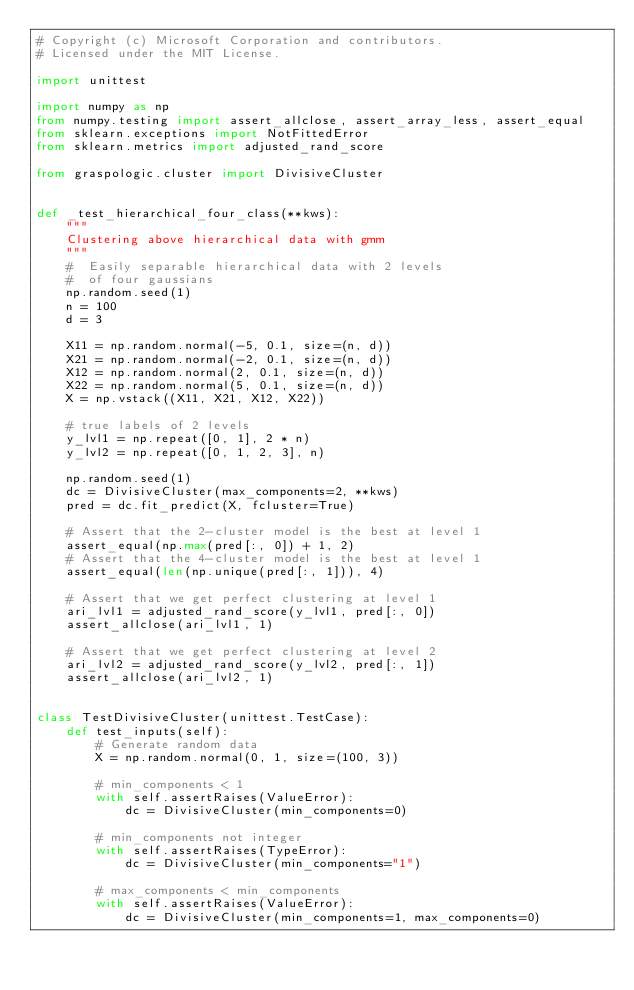<code> <loc_0><loc_0><loc_500><loc_500><_Python_># Copyright (c) Microsoft Corporation and contributors.
# Licensed under the MIT License.

import unittest

import numpy as np
from numpy.testing import assert_allclose, assert_array_less, assert_equal
from sklearn.exceptions import NotFittedError
from sklearn.metrics import adjusted_rand_score

from graspologic.cluster import DivisiveCluster


def _test_hierarchical_four_class(**kws):
    """
    Clustering above hierarchical data with gmm
    """
    #  Easily separable hierarchical data with 2 levels
    #  of four gaussians
    np.random.seed(1)
    n = 100
    d = 3

    X11 = np.random.normal(-5, 0.1, size=(n, d))
    X21 = np.random.normal(-2, 0.1, size=(n, d))
    X12 = np.random.normal(2, 0.1, size=(n, d))
    X22 = np.random.normal(5, 0.1, size=(n, d))
    X = np.vstack((X11, X21, X12, X22))

    # true labels of 2 levels
    y_lvl1 = np.repeat([0, 1], 2 * n)
    y_lvl2 = np.repeat([0, 1, 2, 3], n)

    np.random.seed(1)
    dc = DivisiveCluster(max_components=2, **kws)
    pred = dc.fit_predict(X, fcluster=True)

    # Assert that the 2-cluster model is the best at level 1
    assert_equal(np.max(pred[:, 0]) + 1, 2)
    # Assert that the 4-cluster model is the best at level 1
    assert_equal(len(np.unique(pred[:, 1])), 4)

    # Assert that we get perfect clustering at level 1
    ari_lvl1 = adjusted_rand_score(y_lvl1, pred[:, 0])
    assert_allclose(ari_lvl1, 1)

    # Assert that we get perfect clustering at level 2
    ari_lvl2 = adjusted_rand_score(y_lvl2, pred[:, 1])
    assert_allclose(ari_lvl2, 1)


class TestDivisiveCluster(unittest.TestCase):
    def test_inputs(self):
        # Generate random data
        X = np.random.normal(0, 1, size=(100, 3))

        # min_components < 1
        with self.assertRaises(ValueError):
            dc = DivisiveCluster(min_components=0)

        # min_components not integer
        with self.assertRaises(TypeError):
            dc = DivisiveCluster(min_components="1")

        # max_components < min_components
        with self.assertRaises(ValueError):
            dc = DivisiveCluster(min_components=1, max_components=0)
</code> 